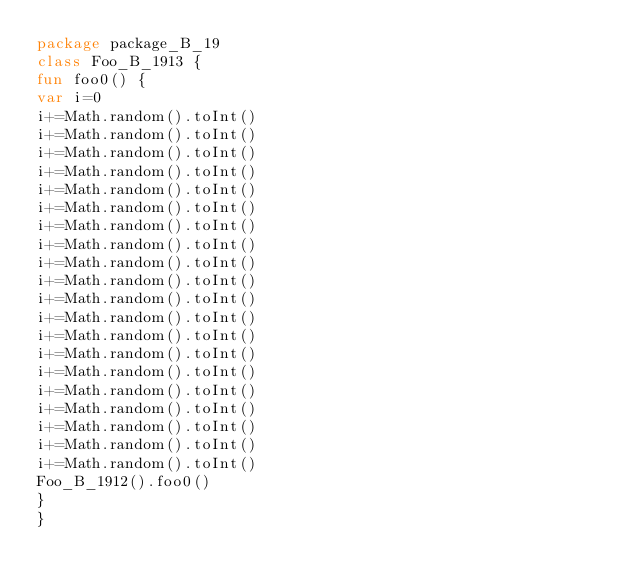<code> <loc_0><loc_0><loc_500><loc_500><_Kotlin_>package package_B_19
class Foo_B_1913 {
fun foo0() {
var i=0
i+=Math.random().toInt()
i+=Math.random().toInt()
i+=Math.random().toInt()
i+=Math.random().toInt()
i+=Math.random().toInt()
i+=Math.random().toInt()
i+=Math.random().toInt()
i+=Math.random().toInt()
i+=Math.random().toInt()
i+=Math.random().toInt()
i+=Math.random().toInt()
i+=Math.random().toInt()
i+=Math.random().toInt()
i+=Math.random().toInt()
i+=Math.random().toInt()
i+=Math.random().toInt()
i+=Math.random().toInt()
i+=Math.random().toInt()
i+=Math.random().toInt()
i+=Math.random().toInt()
Foo_B_1912().foo0()
}
}</code> 